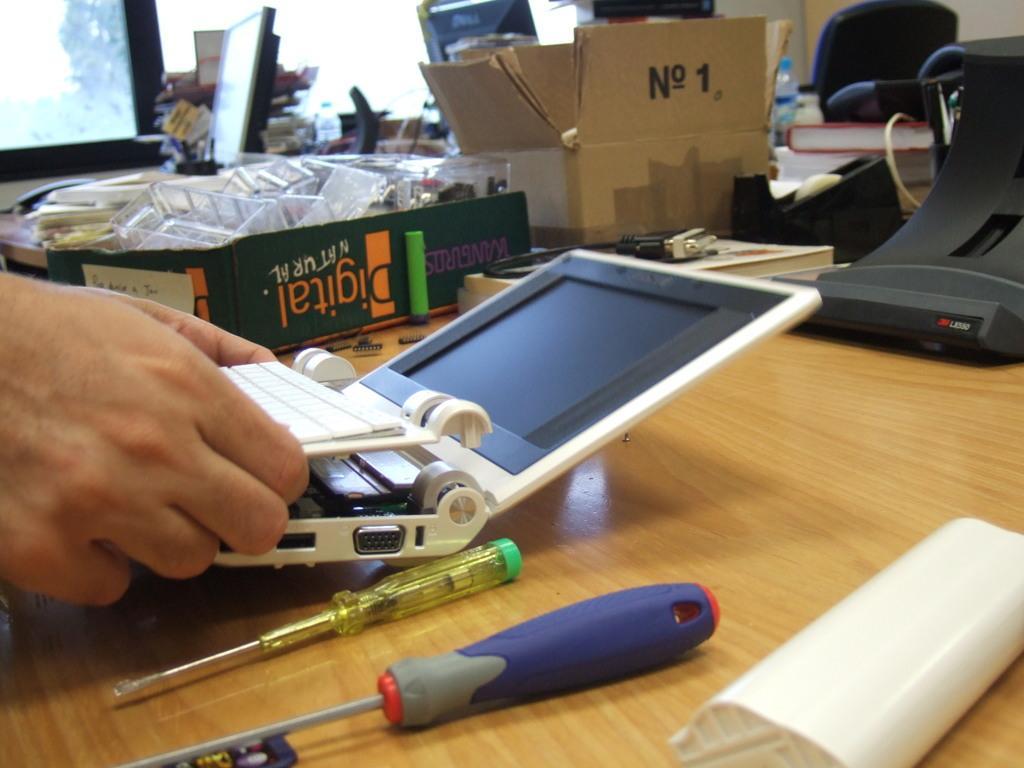In one or two sentences, can you explain what this image depicts? The image is clicked inside the room, where a man might be repairing this laptop, and there are tools on the table. In the background there is window and a computer and there are many accessories kept on the table. 